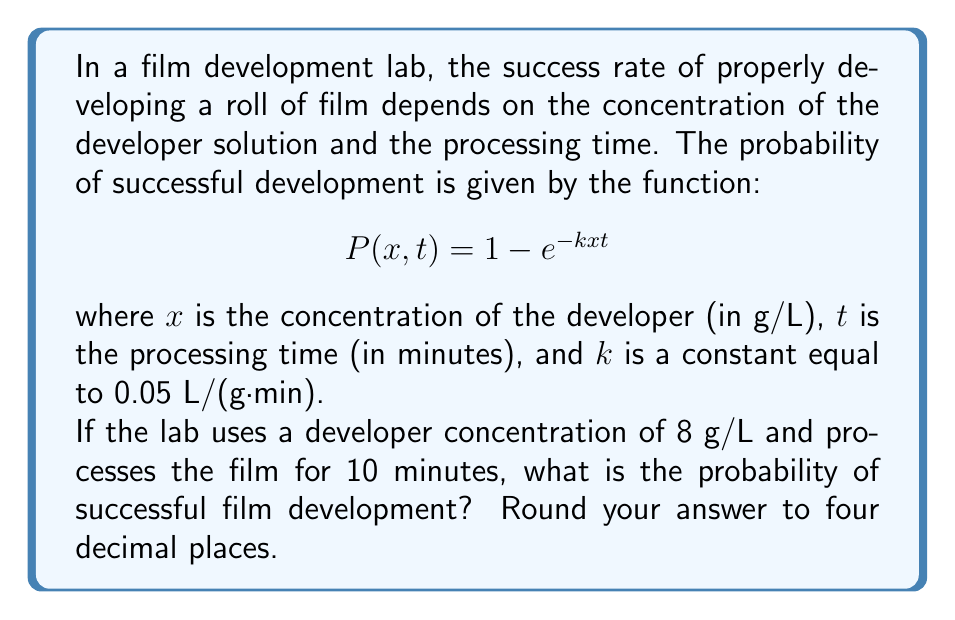What is the answer to this math problem? To solve this problem, we need to use the given probability function and substitute the known values:

1) The given function is:
   $$P(x, t) = 1 - e^{-kxt}$$

2) We know the following values:
   - $x = 8$ g/L (developer concentration)
   - $t = 10$ minutes (processing time)
   - $k = 0.05$ L/(g·min) (given constant)

3) Let's substitute these values into the function:
   $$P(8, 10) = 1 - e^{-0.05 \cdot 8 \cdot 10}$$

4) Simplify the exponent:
   $$P(8, 10) = 1 - e^{-4}$$

5) Calculate the value of $e^{-4}$:
   $$e^{-4} \approx 0.0183$$

6) Subtract this value from 1:
   $$P(8, 10) = 1 - 0.0183 \approx 0.9817$$

7) Rounding to four decimal places:
   $$P(8, 10) \approx 0.9817$$

Therefore, the probability of successful film development under these conditions is approximately 0.9817 or 98.17%.
Answer: 0.9817 